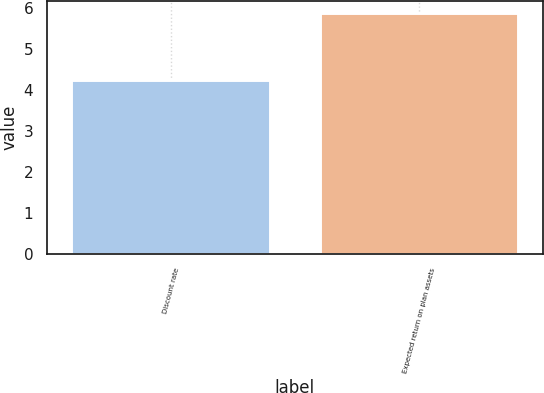<chart> <loc_0><loc_0><loc_500><loc_500><bar_chart><fcel>Discount rate<fcel>Expected return on plan assets<nl><fcel>4.24<fcel>5.87<nl></chart> 